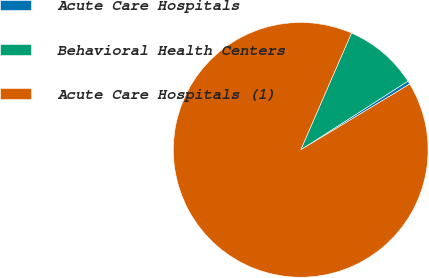Convert chart. <chart><loc_0><loc_0><loc_500><loc_500><pie_chart><fcel>Acute Care Hospitals<fcel>Behavioral Health Centers<fcel>Acute Care Hospitals (1)<nl><fcel>0.43%<fcel>9.4%<fcel>90.16%<nl></chart> 